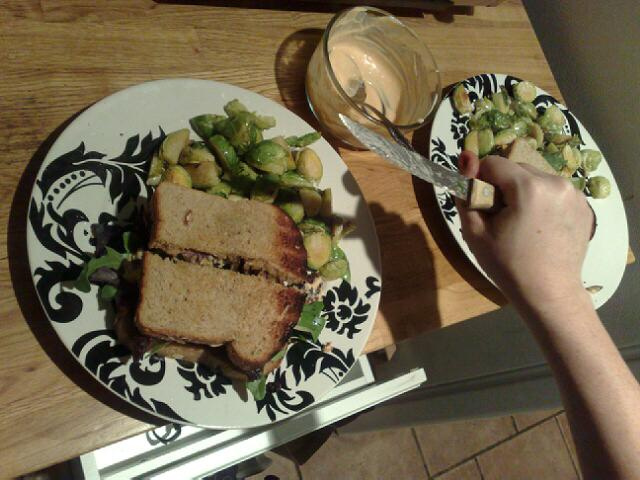<image>What utensil is on the plate? I am not sure. There might be a knife on the plate but possibilities also exist that there is no utensil on the plate. What utensil is on the plate? I am not sure what utensil is on the plate. It can be seen both knife or none. 